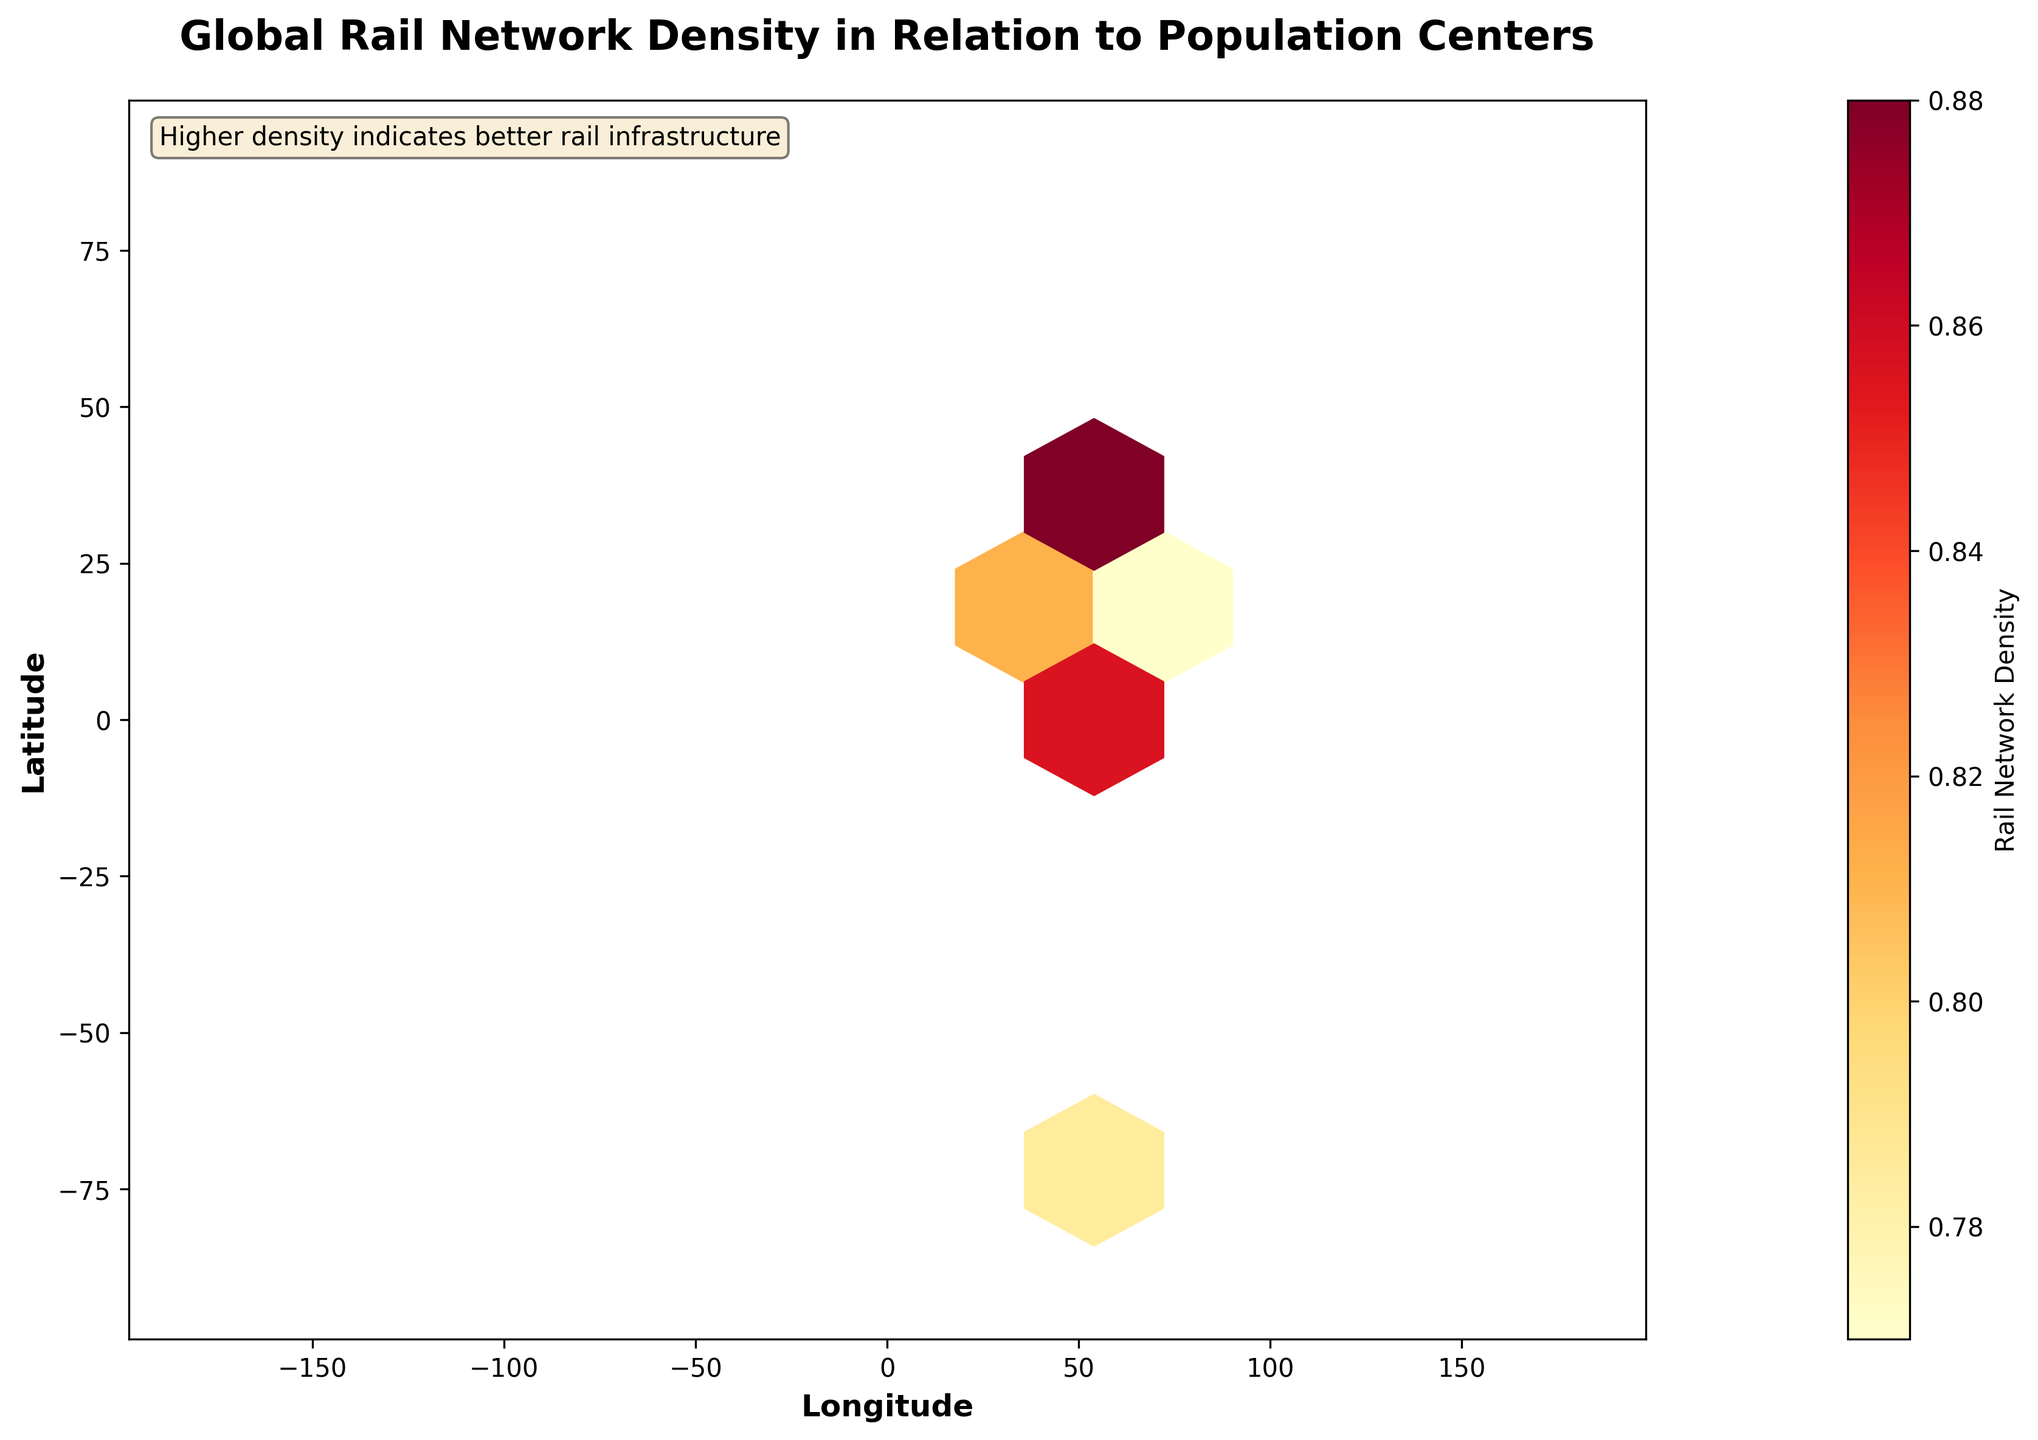What is the title of the figure? The title of the figure is displayed prominently at the top and reads "Global Rail Network Density in Relation to Population Centers".
Answer: Global Rail Network Density in Relation to Population Centers What do the colors in the hexagons represent? The color scale shown in the color bar on the right represents rail network density, with warmer colors (yellow to red) indicating higher density.
Answer: Rail network density What is the approximate rail network density for Tokyo? Locate Tokyo on the plot around the coordinates (35.6762, 139.6503), which corresponds to a density value around 0.95 as indicated by the color bar.
Answer: 0.95 How is information about rail network density conveyed in the plot? Rail network density is conveyed using a color gradient within hexagonal bins, which represent different density levels according to the color bar on the right.
Answer: Using color gradient within hexagonal bins What can we infer about the rail network density in population centers in Europe compared to Asia? By visually comparing hexagons over Europe and Asia, we see that there are a number of darker hexagons in both regions, suggesting relatively high rail network densities, with Asia having slightly more hexagons in the highest density range.
Answer: Both have high densities, Asia slightly higher Which city has the highest rail network density according to the figure? Identify the city positioned closest to the hexagons with the darkest colors and compare density values; for example, locate Beijing with coordinates approximately (39.9042, 116.4074) and a density of 0.93.
Answer: Tokyo Is there a correlation between longitude and rail network density? Examine the hexagons along the longitude axis and observe variations in color; the density seems to be spread across both eastern and western longitudes without a clear trend.
Answer: No clear correlation Which region seems to show more variance in rail network density, Europe or North America? Compare the hexagons over Europe and North America; Europe shows a more consistent density (more uniform colors), whereas North America shows a greater color variation indicating more variance in density.
Answer: North America How does the density of rail networks in China compare to that in Germany? Locate China around (31.2304, 121.4737) and observe the color, which is around 0.91, and compare to Germany around (51.1657, 10.4515) with a density of 0.87. Thus, China has a higher density.
Answer: China has higher density What information is given in the annotation text box on the figure? The annotation text box at the bottom left of the figure provides additional context: "Higher density indicates better rail infrastructure".
Answer: Higher density indicates better rail infrastructure 